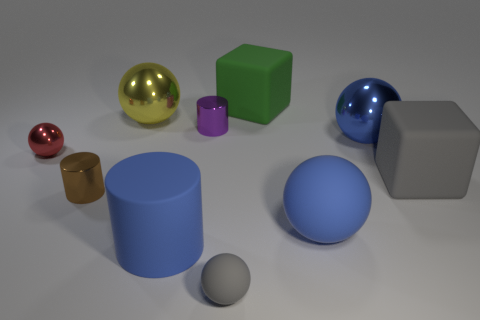There is a big cylinder; is its color the same as the metal ball to the right of the small matte object?
Offer a terse response. Yes. There is a large sphere that is to the left of the gray ball; what is its material?
Provide a short and direct response. Metal. Is there a ball that has the same color as the large cylinder?
Give a very brief answer. Yes. There is a cylinder that is the same size as the green cube; what is its color?
Ensure brevity in your answer.  Blue. What number of big objects are either red objects or yellow metal things?
Your answer should be very brief. 1. Is the number of red metal spheres behind the tiny matte object the same as the number of yellow things that are to the left of the blue shiny ball?
Make the answer very short. Yes. What number of cubes are the same size as the red metal ball?
Provide a succinct answer. 0. How many cyan things are either spheres or large spheres?
Your answer should be very brief. 0. Are there the same number of spheres that are behind the small red thing and large cubes?
Your answer should be compact. Yes. There is a metal object to the left of the tiny brown object; what is its size?
Your answer should be compact. Small. 